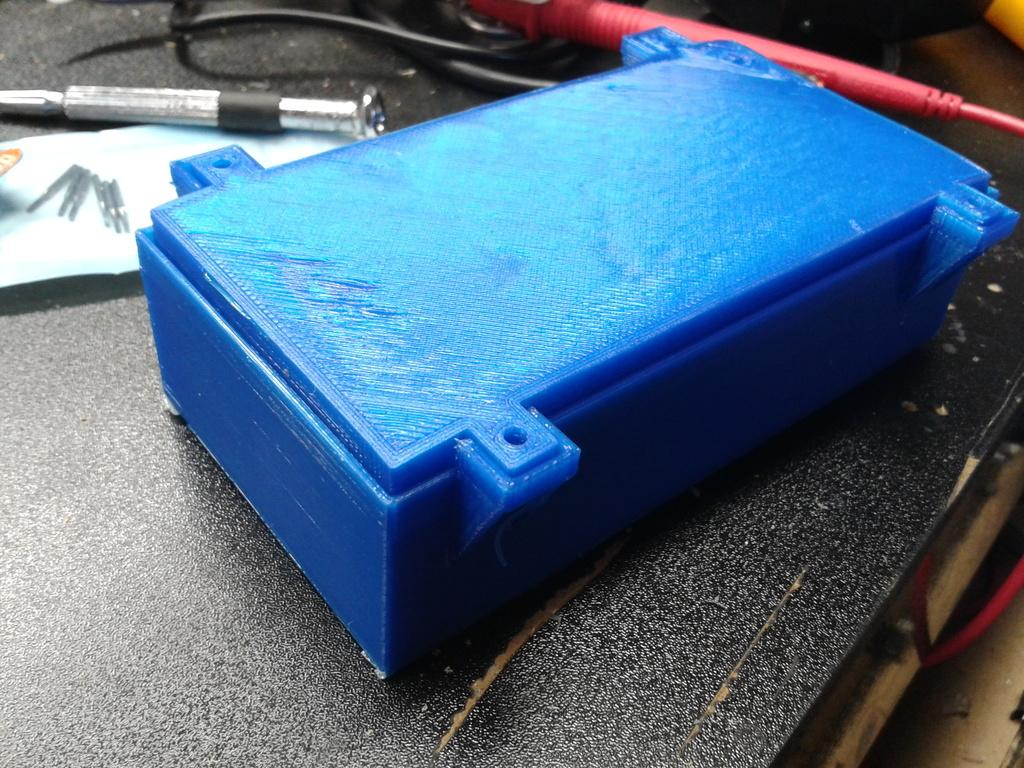What is the main object in the center of the image? There is a blue color box in the center of the image. What is placed on the paper near the box? There are needles on the paper. What can be seen on the table in the image? There are objects and wires on the table. What type of offer is being made in the image? There is no offer being made in the image; it only shows a blue color box, needles on a paper, and objects and wires on a table. Can you describe the journey depicted in the image? There is no journey depicted in the image; it only shows a blue color box, needles on a paper, and objects and wires on a table. 